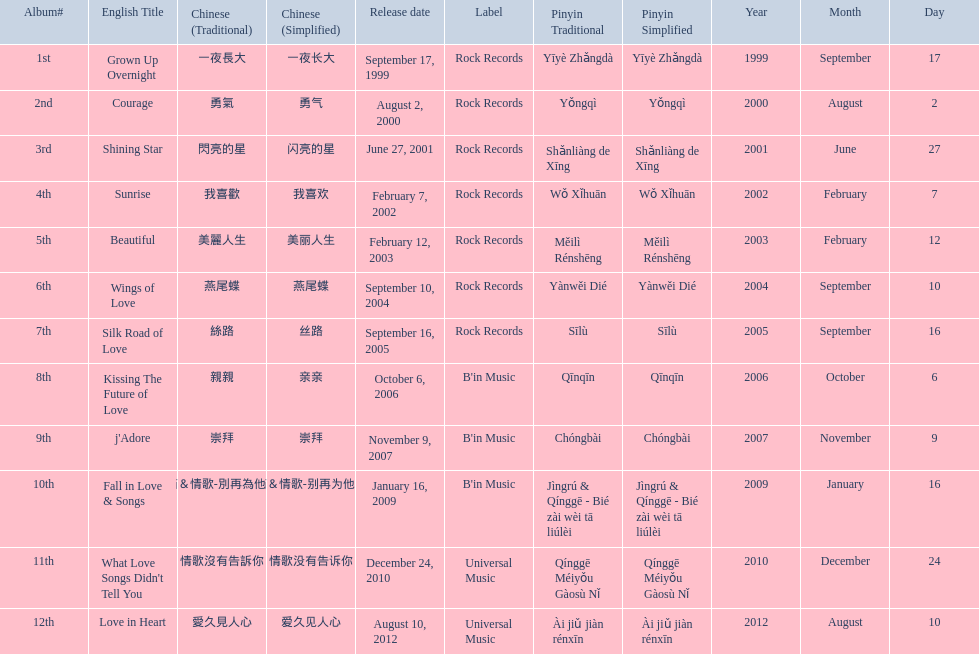Which was the only album to be released by b'in music in an even-numbered year? Kissing The Future of Love. 